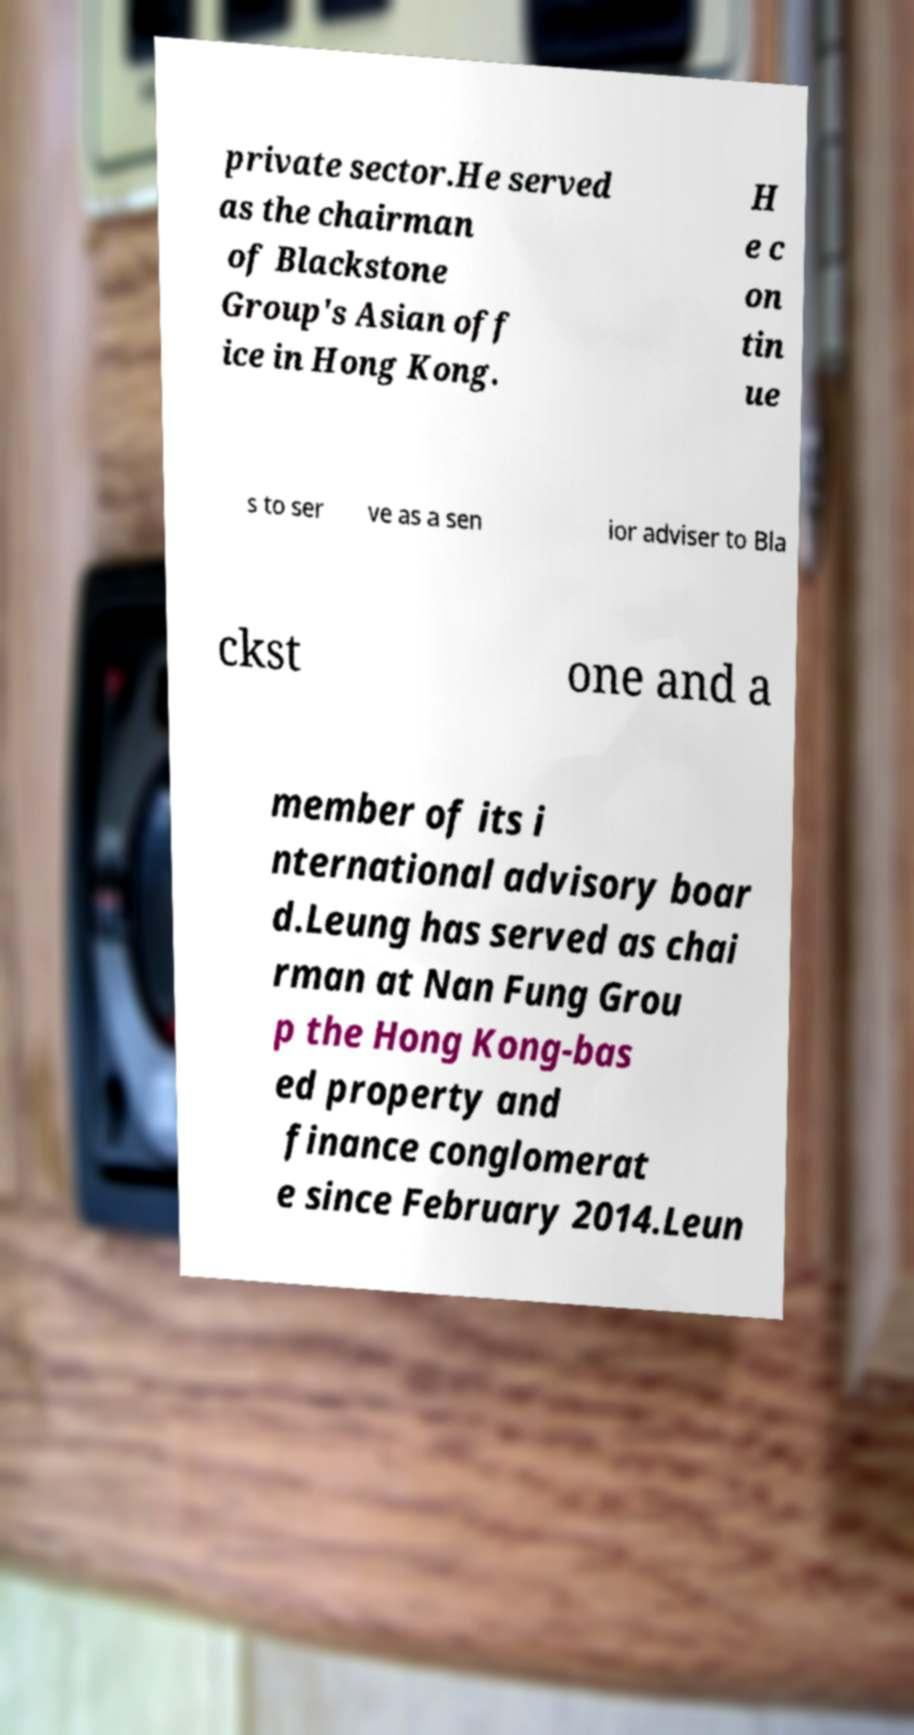Can you accurately transcribe the text from the provided image for me? private sector.He served as the chairman of Blackstone Group's Asian off ice in Hong Kong. H e c on tin ue s to ser ve as a sen ior adviser to Bla ckst one and a member of its i nternational advisory boar d.Leung has served as chai rman at Nan Fung Grou p the Hong Kong-bas ed property and finance conglomerat e since February 2014.Leun 